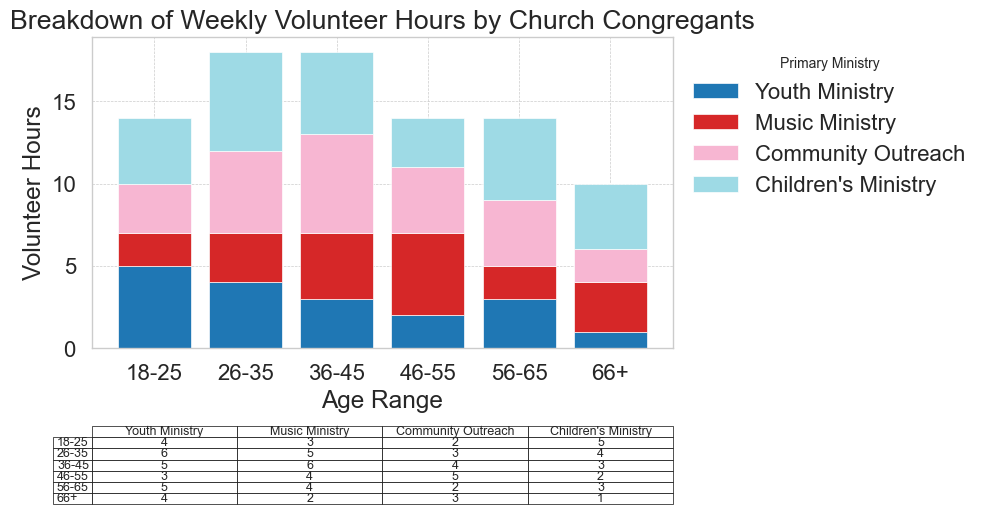Which age group contributes the most volunteer hours to the Children's Ministry? We look at the 'Children's Ministry' column in the table. The 26-35 age group contributes 6 hours, which is the highest.
Answer: 26-35 How many total volunteer hours are contributed by the 36-45 age group? Sum the hours across all ministries for the 36-45 age group: 3 (Youth Ministry) + 4 (Music Ministry) + 6 (Community Outreach) + 5 (Children's Ministry) = 18.
Answer: 18 What is the difference in volunteer hours between the Music Ministry and Community Outreach for the 46-55 age group? Subtract the hours of Community Outreach from Music Ministry for the 46-55 age group: 5 (Music Ministry) - 4 (Community Outreach) = 1.
Answer: 1 Which ministry receives the least amount of volunteer hours from the 66+ age group? Look at the hours in the table for the 66+ age group and find the minimum value: 1 hour is the lowest, which is for Youth Ministry.
Answer: Youth Ministry What are the total volunteer hours for all age groups in the Youth Ministry? Sum the hours across all age groups for the Youth Ministry: 5 (18-25) + 4 (26-35) + 3 (36-45) + 2 (46-55) + 3 (56-65) + 1 (66+) = 18.
Answer: 18 Which age group has the highest total volunteer hours, and which ministry contributes the most within that age group? Calculate the sum of hours across all ministries for each age group: 18-25 (14), 26-35 (18), 36-45 (18), 46-55 (14), 56-65 (14), 66+ (10). Both 26-35 and 36-45 age groups have the highest total hours (18). For the 26-35 group, Children's Ministry contributes the most (6 hours), and for the 36-45 group, Community Outreach and Children's Ministry each contribute 6 and 5 hours respectively. Analyzing these contributions identifies the 26-35 group and the Children's Ministry as the most significant primary contributions.
Answer: 26-35, Children's Ministry Considering the table, which ministry has the most consistent volunteer hours across all age groups? Look for a ministry where the variation in hours across age groups is minimal. Music Ministry has hours of 2, 3, 4, 5, 2, and 3 for the respective age groups, showing less variation compared to other ministries.
Answer: Music Ministry If we want to increase volunteer engagement, which age group and ministry combination should be targeted based on the current distribution? Based on lower contributions and potential for growth, targeting the 66+ age group and the Youth Ministry (1 hour) could increase engagement.
Answer: 66+, Youth Ministry How do the total volunteer hours for the 18-25 and 56-65 age groups compare? Sum the total hours for both age groups: 18-25 group (5+2+3+4 = 14) and 56-65 group (3+2+4+5 = 14). Both groups have equal total volunteer hours.
Answer: They are equal 